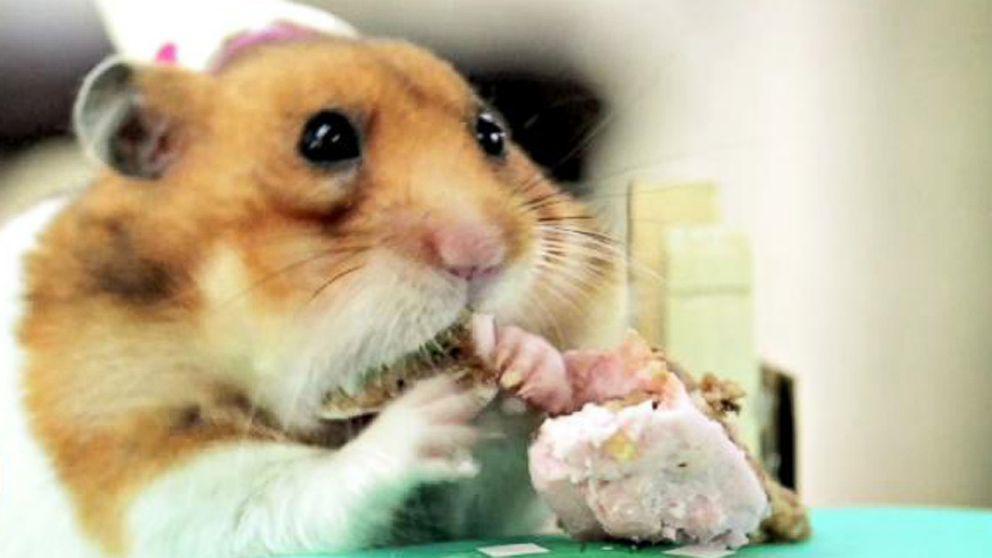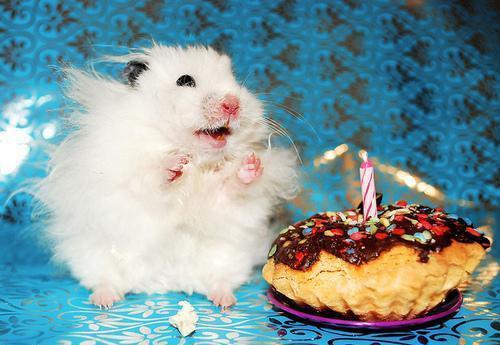The first image is the image on the left, the second image is the image on the right. Assess this claim about the two images: "The surface in one of the images is not covered by a table cloth.". Correct or not? Answer yes or no. No. 